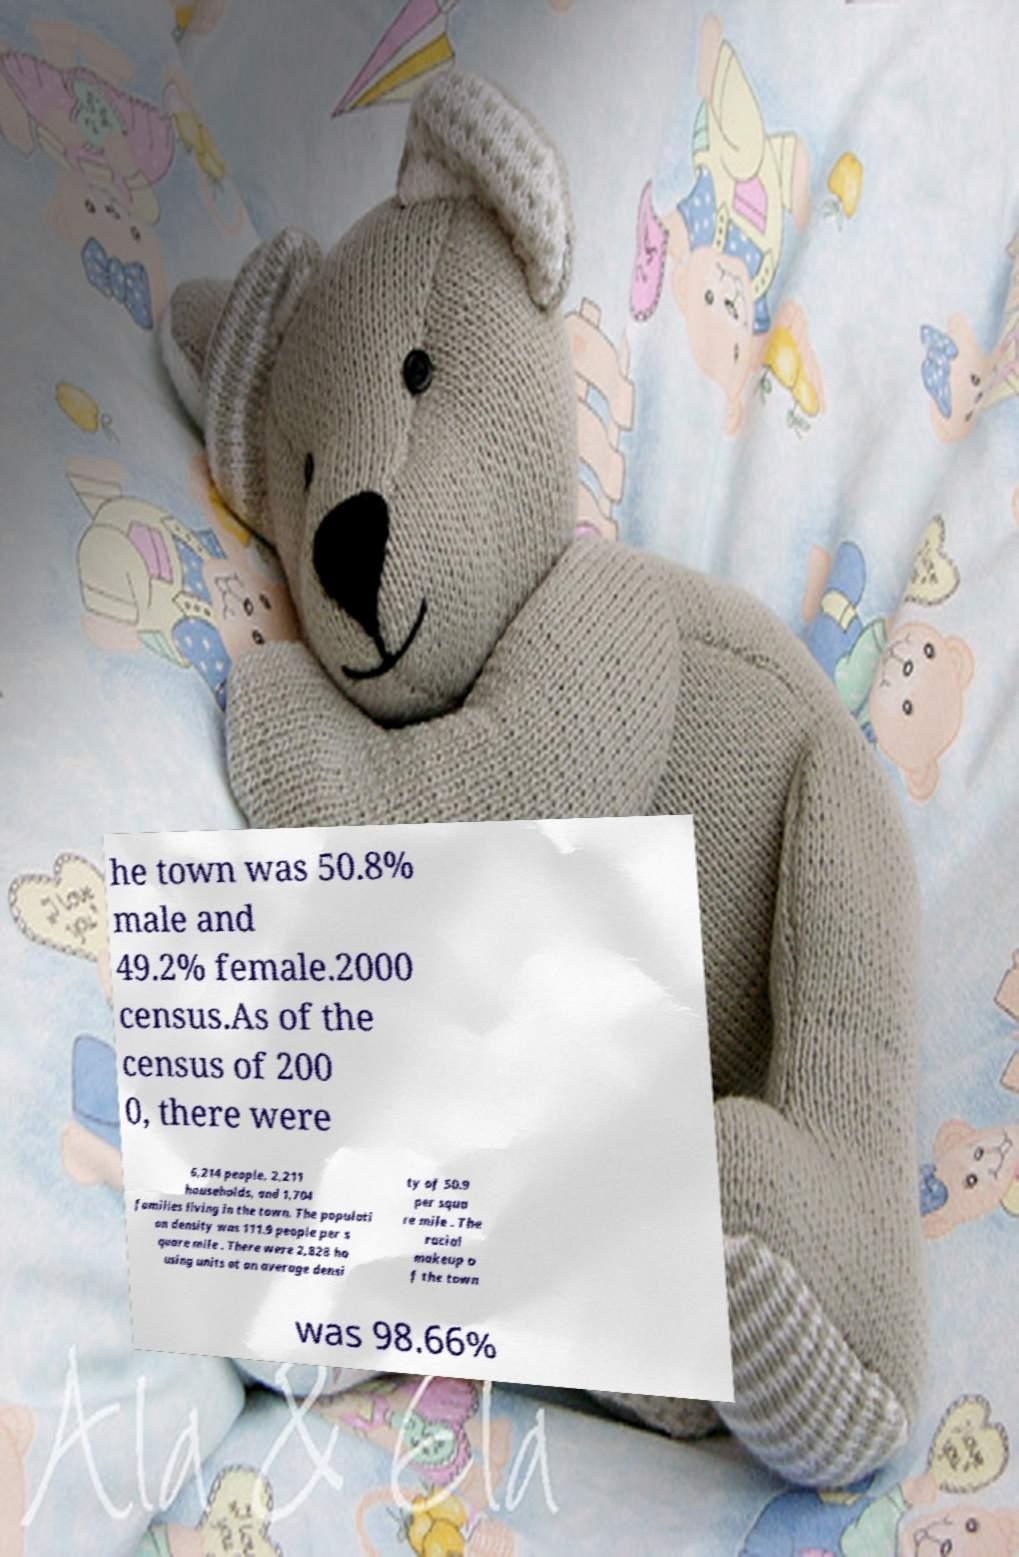Could you assist in decoding the text presented in this image and type it out clearly? he town was 50.8% male and 49.2% female.2000 census.As of the census of 200 0, there were 6,214 people, 2,211 households, and 1,704 families living in the town. The populati on density was 111.9 people per s quare mile . There were 2,828 ho using units at an average densi ty of 50.9 per squa re mile . The racial makeup o f the town was 98.66% 